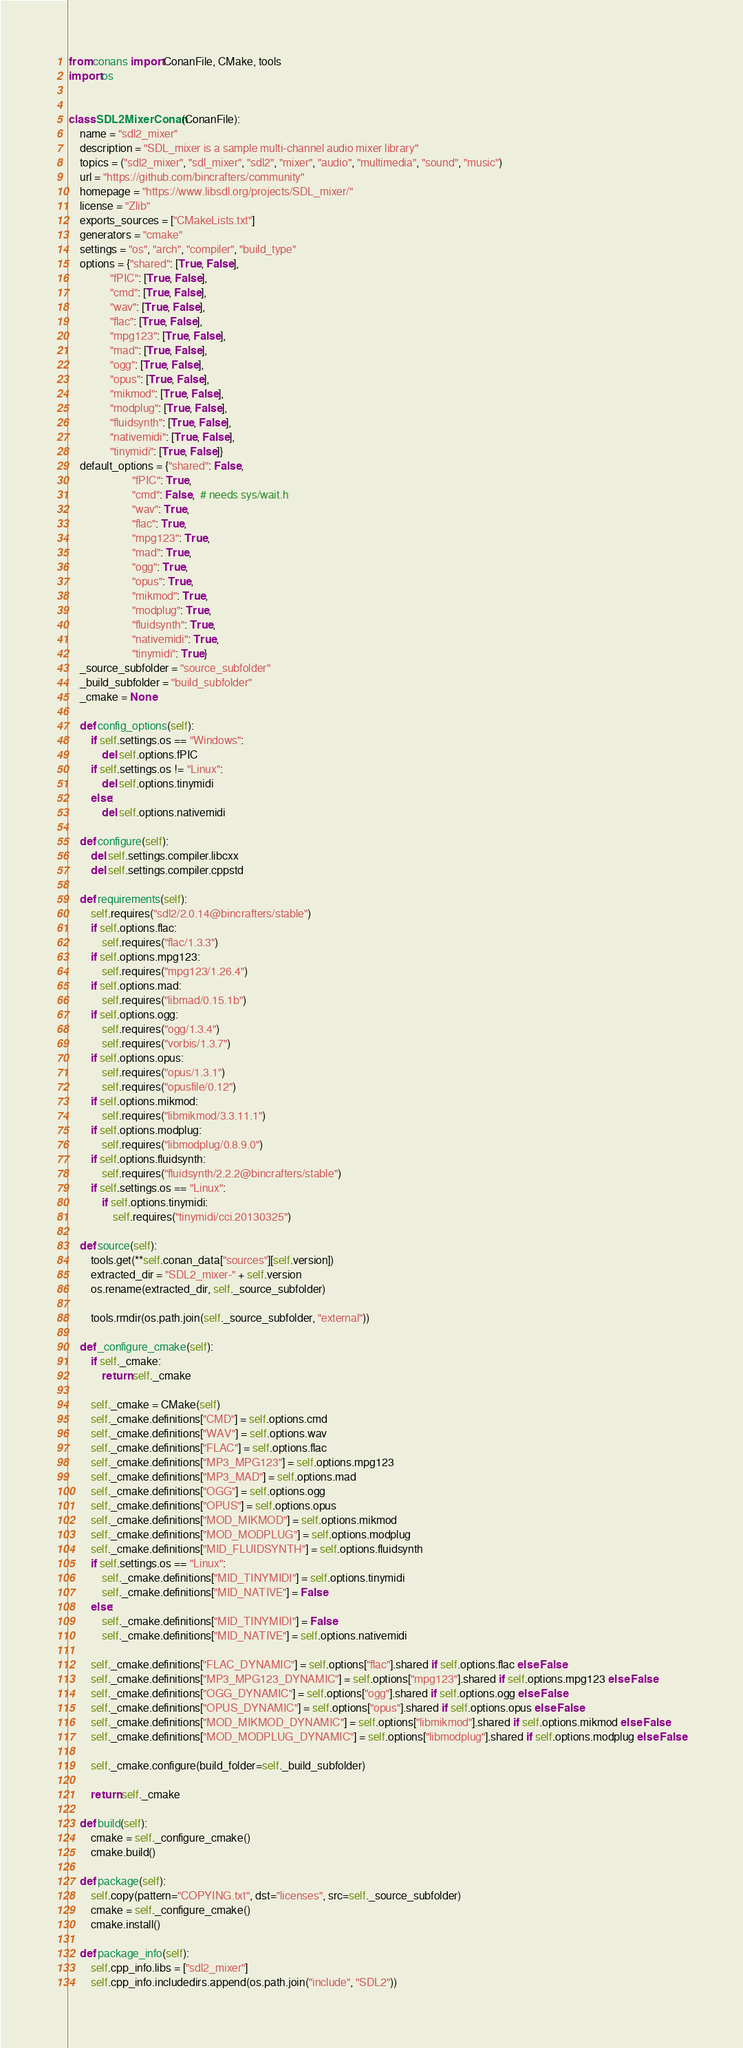Convert code to text. <code><loc_0><loc_0><loc_500><loc_500><_Python_>from conans import ConanFile, CMake, tools
import os


class SDL2MixerConan(ConanFile):
    name = "sdl2_mixer"
    description = "SDL_mixer is a sample multi-channel audio mixer library"
    topics = ("sdl2_mixer", "sdl_mixer", "sdl2", "mixer", "audio", "multimedia", "sound", "music")
    url = "https://github.com/bincrafters/community"
    homepage = "https://www.libsdl.org/projects/SDL_mixer/"
    license = "Zlib"
    exports_sources = ["CMakeLists.txt"]
    generators = "cmake"
    settings = "os", "arch", "compiler", "build_type"
    options = {"shared": [True, False],
               "fPIC": [True, False],
               "cmd": [True, False],
               "wav": [True, False],
               "flac": [True, False],
               "mpg123": [True, False],
               "mad": [True, False],
               "ogg": [True, False],
               "opus": [True, False],
               "mikmod": [True, False],
               "modplug": [True, False],
               "fluidsynth": [True, False],
               "nativemidi": [True, False],
               "tinymidi": [True, False]}
    default_options = {"shared": False,
                       "fPIC": True,
                       "cmd": False,  # needs sys/wait.h
                       "wav": True,
                       "flac": True,
                       "mpg123": True,
                       "mad": True,
                       "ogg": True,
                       "opus": True,
                       "mikmod": True,
                       "modplug": True,
                       "fluidsynth": True,
                       "nativemidi": True,
                       "tinymidi": True}
    _source_subfolder = "source_subfolder"
    _build_subfolder = "build_subfolder"
    _cmake = None

    def config_options(self):
        if self.settings.os == "Windows":
            del self.options.fPIC
        if self.settings.os != "Linux":
            del self.options.tinymidi
        else:
            del self.options.nativemidi

    def configure(self):
        del self.settings.compiler.libcxx
        del self.settings.compiler.cppstd

    def requirements(self):
        self.requires("sdl2/2.0.14@bincrafters/stable")
        if self.options.flac:
            self.requires("flac/1.3.3")
        if self.options.mpg123:
            self.requires("mpg123/1.26.4")
        if self.options.mad:
            self.requires("libmad/0.15.1b")
        if self.options.ogg:
            self.requires("ogg/1.3.4")
            self.requires("vorbis/1.3.7")
        if self.options.opus:
            self.requires("opus/1.3.1")
            self.requires("opusfile/0.12")
        if self.options.mikmod:
            self.requires("libmikmod/3.3.11.1")
        if self.options.modplug:
            self.requires("libmodplug/0.8.9.0")
        if self.options.fluidsynth:
            self.requires("fluidsynth/2.2.2@bincrafters/stable")
        if self.settings.os == "Linux":
            if self.options.tinymidi:
                self.requires("tinymidi/cci.20130325")

    def source(self):
        tools.get(**self.conan_data["sources"][self.version])
        extracted_dir = "SDL2_mixer-" + self.version
        os.rename(extracted_dir, self._source_subfolder)

        tools.rmdir(os.path.join(self._source_subfolder, "external"))

    def _configure_cmake(self):
        if self._cmake:
            return self._cmake

        self._cmake = CMake(self)
        self._cmake.definitions["CMD"] = self.options.cmd
        self._cmake.definitions["WAV"] = self.options.wav
        self._cmake.definitions["FLAC"] = self.options.flac
        self._cmake.definitions["MP3_MPG123"] = self.options.mpg123
        self._cmake.definitions["MP3_MAD"] = self.options.mad
        self._cmake.definitions["OGG"] = self.options.ogg
        self._cmake.definitions["OPUS"] = self.options.opus
        self._cmake.definitions["MOD_MIKMOD"] = self.options.mikmod
        self._cmake.definitions["MOD_MODPLUG"] = self.options.modplug
        self._cmake.definitions["MID_FLUIDSYNTH"] = self.options.fluidsynth
        if self.settings.os == "Linux":
            self._cmake.definitions["MID_TINYMIDI"] = self.options.tinymidi
            self._cmake.definitions["MID_NATIVE"] = False
        else:
            self._cmake.definitions["MID_TINYMIDI"] = False
            self._cmake.definitions["MID_NATIVE"] = self.options.nativemidi

        self._cmake.definitions["FLAC_DYNAMIC"] = self.options["flac"].shared if self.options.flac else False
        self._cmake.definitions["MP3_MPG123_DYNAMIC"] = self.options["mpg123"].shared if self.options.mpg123 else False
        self._cmake.definitions["OGG_DYNAMIC"] = self.options["ogg"].shared if self.options.ogg else False
        self._cmake.definitions["OPUS_DYNAMIC"] = self.options["opus"].shared if self.options.opus else False
        self._cmake.definitions["MOD_MIKMOD_DYNAMIC"] = self.options["libmikmod"].shared if self.options.mikmod else False
        self._cmake.definitions["MOD_MODPLUG_DYNAMIC"] = self.options["libmodplug"].shared if self.options.modplug else False

        self._cmake.configure(build_folder=self._build_subfolder)

        return self._cmake

    def build(self):
        cmake = self._configure_cmake()
        cmake.build()

    def package(self):
        self.copy(pattern="COPYING.txt", dst="licenses", src=self._source_subfolder)
        cmake = self._configure_cmake()
        cmake.install()

    def package_info(self):
        self.cpp_info.libs = ["sdl2_mixer"]
        self.cpp_info.includedirs.append(os.path.join("include", "SDL2"))
</code> 